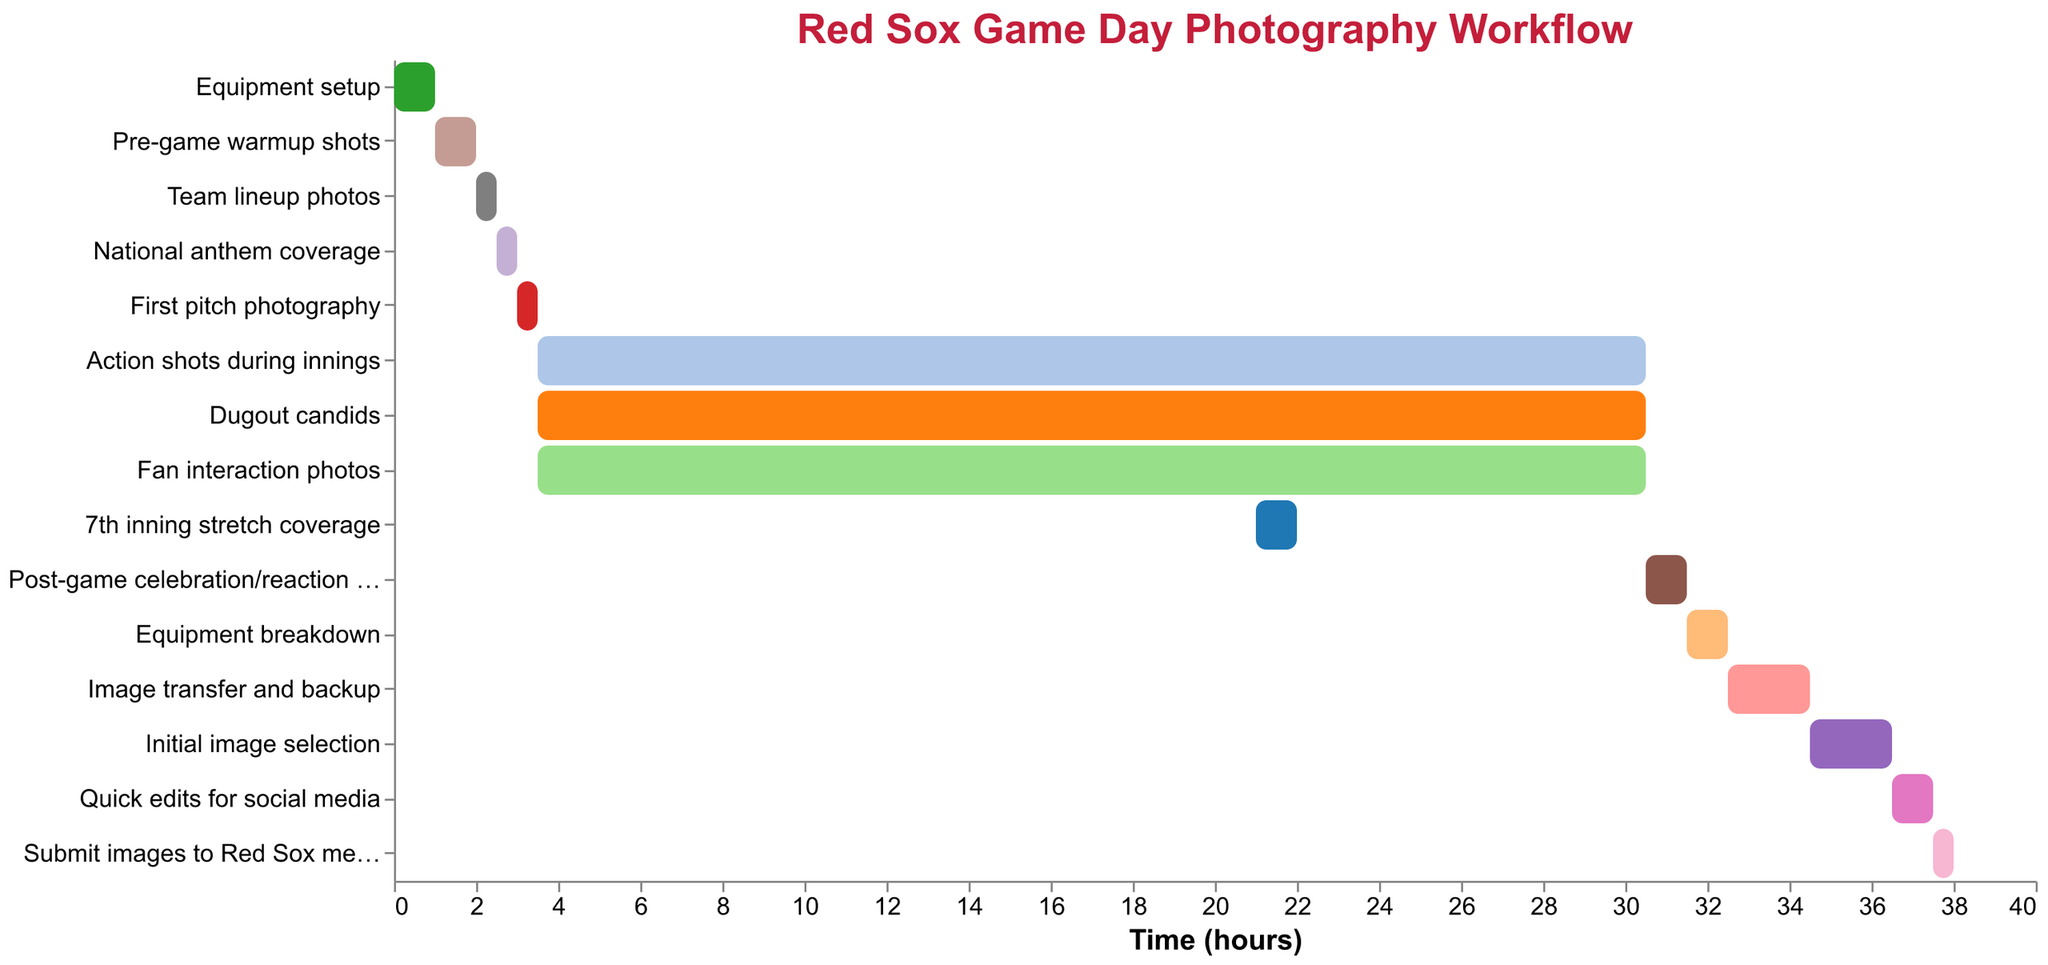what's the title of the figure? The title is located at the top of the Gantt Chart and indicates the overall theme or purpose of the chart.
Answer: Red Sox Game Day Photography Workflow what's the duration of 'First pitch photography'? Find the task "First pitch photography" on the y-axis and check its corresponding duration on the chart.
Answer: 0.5 hours which tasks start at the same time as 'Action shots during innings'? Identify the start time of "Action shots during innings" and note any other tasks beginning at this time.
Answer: Dugout candids, Fan interaction photos how long is 'Equipment breakdown' compared to 'Team lineup photos'? Compare the durations of "Equipment breakdown" and "Team lineup photos" from the chart.
Answer: 0.5 hours longer what tasks start immediately after 'National anthem coverage'? Find the end time of "National anthem coverage" and check which tasks start directly after this time.
Answer: First pitch photography when does '7th inning stretch coverage' begin? Locate "7th inning stretch coverage" on the chart and read its start time horizontally from the x-axis.
Answer: 21 hours what is the total duration of tasks performed after the game ends? Identify all tasks after 30.5 hours (post-game) and sum their durations: "Post-game celebration/reaction shots," "Equipment breakdown," "Image transfer and backup," "Initial image selection," "Quick edits for social media," "Submit images to Red Sox media team."
Answer: 7 hours which task has the shortest duration? Find the task with the smallest horizontal bar (shortest duration) on the chart.
Answer: Team lineup photos during which period are most tasks happening simultaneously? Observe the section of the chart with the highest density of overlapping tasks, specifically checking their timelines.
Answer: 3.5 to 30.5 hours how much time is spent on 'Image transfer and backup' and 'Initial image selection' combined? Add the durations of the "Image transfer and backup" and "Initial image selection" tasks from the chart.
Answer: 4 hours 